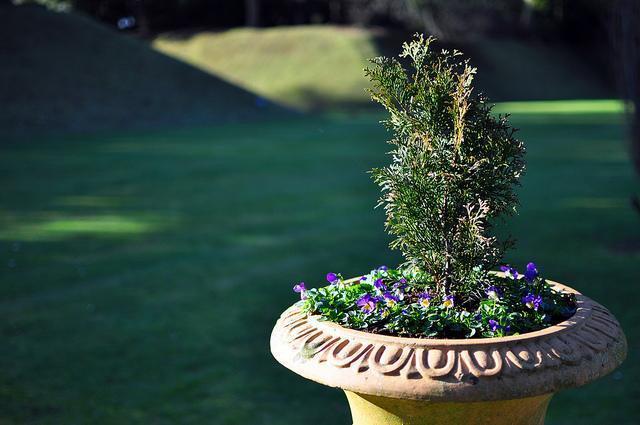How many vases can you see?
Give a very brief answer. 1. How many people are walking toward the building?
Give a very brief answer. 0. 